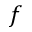<formula> <loc_0><loc_0><loc_500><loc_500>f</formula> 